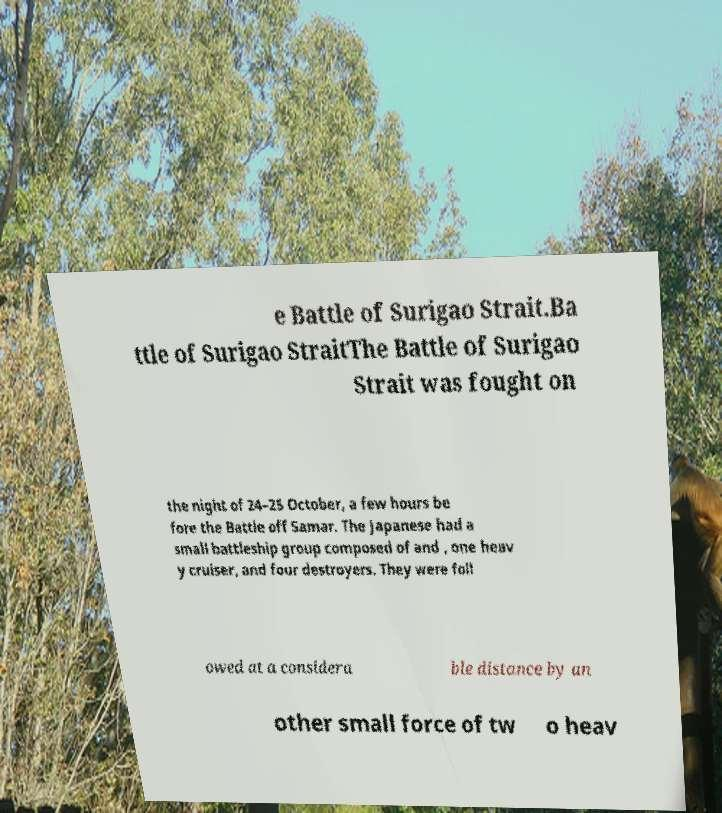Can you read and provide the text displayed in the image?This photo seems to have some interesting text. Can you extract and type it out for me? e Battle of Surigao Strait.Ba ttle of Surigao StraitThe Battle of Surigao Strait was fought on the night of 24–25 October, a few hours be fore the Battle off Samar. The Japanese had a small battleship group composed of and , one heav y cruiser, and four destroyers. They were foll owed at a considera ble distance by an other small force of tw o heav 